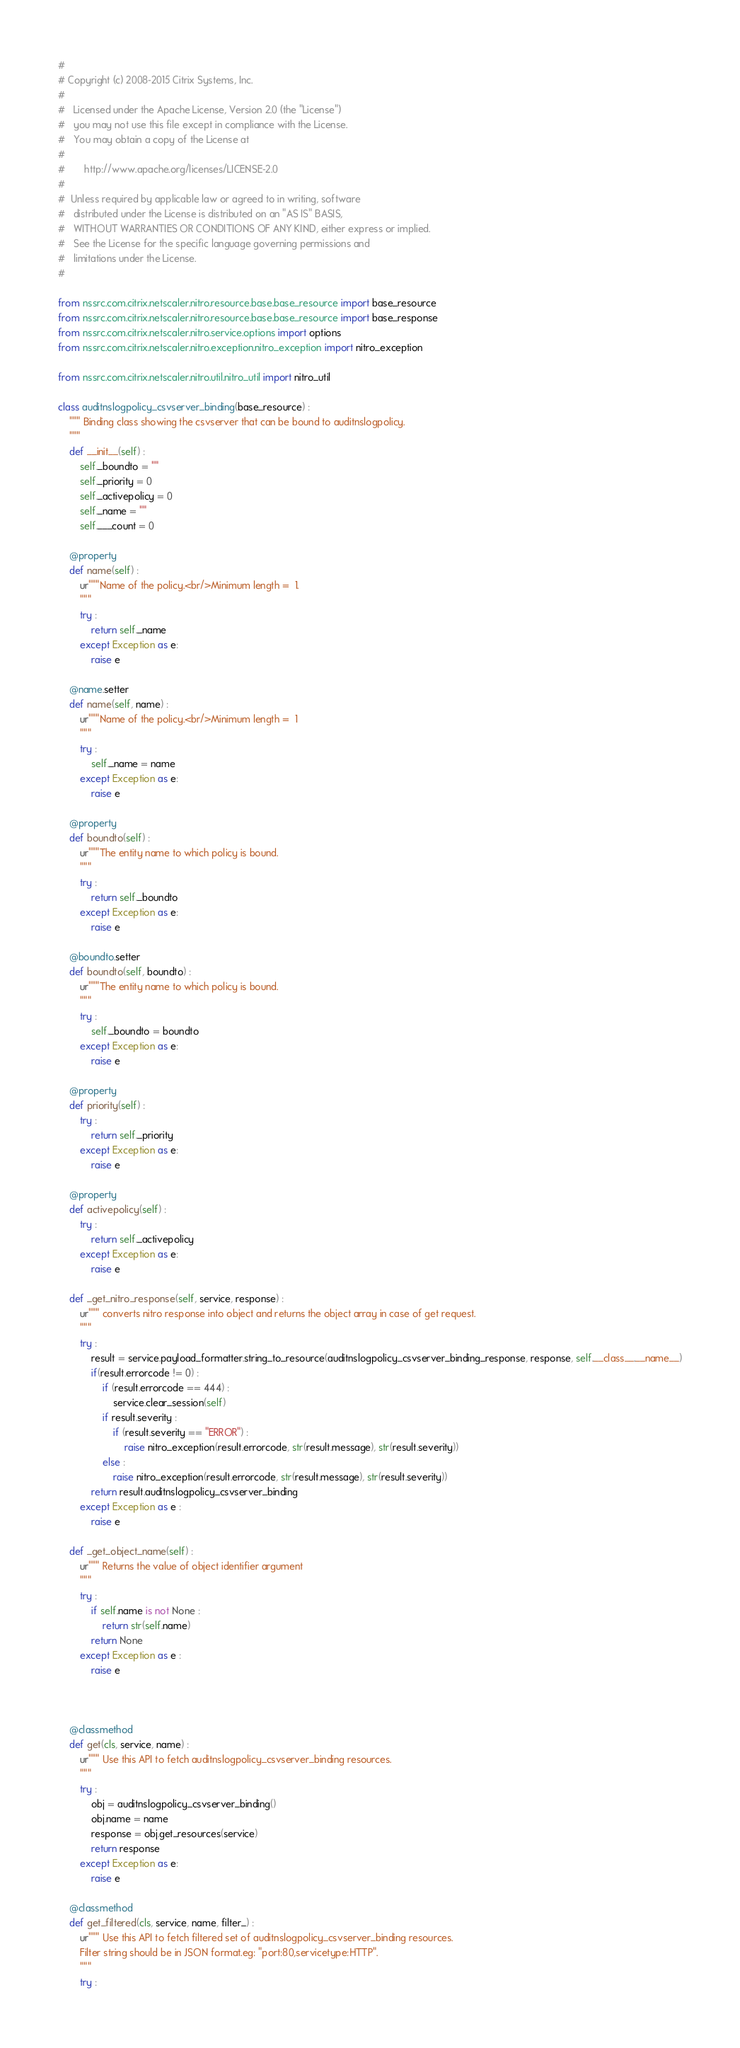<code> <loc_0><loc_0><loc_500><loc_500><_Python_>#
# Copyright (c) 2008-2015 Citrix Systems, Inc.
#
#   Licensed under the Apache License, Version 2.0 (the "License")
#   you may not use this file except in compliance with the License.
#   You may obtain a copy of the License at
#
#       http://www.apache.org/licenses/LICENSE-2.0
#
#  Unless required by applicable law or agreed to in writing, software
#   distributed under the License is distributed on an "AS IS" BASIS,
#   WITHOUT WARRANTIES OR CONDITIONS OF ANY KIND, either express or implied.
#   See the License for the specific language governing permissions and
#   limitations under the License.
#

from nssrc.com.citrix.netscaler.nitro.resource.base.base_resource import base_resource
from nssrc.com.citrix.netscaler.nitro.resource.base.base_resource import base_response
from nssrc.com.citrix.netscaler.nitro.service.options import options
from nssrc.com.citrix.netscaler.nitro.exception.nitro_exception import nitro_exception

from nssrc.com.citrix.netscaler.nitro.util.nitro_util import nitro_util

class auditnslogpolicy_csvserver_binding(base_resource) :
	""" Binding class showing the csvserver that can be bound to auditnslogpolicy.
	"""
	def __init__(self) :
		self._boundto = ""
		self._priority = 0
		self._activepolicy = 0
		self._name = ""
		self.___count = 0

	@property
	def name(self) :
		ur"""Name of the policy.<br/>Minimum length =  1.
		"""
		try :
			return self._name
		except Exception as e:
			raise e

	@name.setter
	def name(self, name) :
		ur"""Name of the policy.<br/>Minimum length =  1
		"""
		try :
			self._name = name
		except Exception as e:
			raise e

	@property
	def boundto(self) :
		ur"""The entity name to which policy is bound.
		"""
		try :
			return self._boundto
		except Exception as e:
			raise e

	@boundto.setter
	def boundto(self, boundto) :
		ur"""The entity name to which policy is bound.
		"""
		try :
			self._boundto = boundto
		except Exception as e:
			raise e

	@property
	def priority(self) :
		try :
			return self._priority
		except Exception as e:
			raise e

	@property
	def activepolicy(self) :
		try :
			return self._activepolicy
		except Exception as e:
			raise e

	def _get_nitro_response(self, service, response) :
		ur""" converts nitro response into object and returns the object array in case of get request.
		"""
		try :
			result = service.payload_formatter.string_to_resource(auditnslogpolicy_csvserver_binding_response, response, self.__class__.__name__)
			if(result.errorcode != 0) :
				if (result.errorcode == 444) :
					service.clear_session(self)
				if result.severity :
					if (result.severity == "ERROR") :
						raise nitro_exception(result.errorcode, str(result.message), str(result.severity))
				else :
					raise nitro_exception(result.errorcode, str(result.message), str(result.severity))
			return result.auditnslogpolicy_csvserver_binding
		except Exception as e :
			raise e

	def _get_object_name(self) :
		ur""" Returns the value of object identifier argument
		"""
		try :
			if self.name is not None :
				return str(self.name)
			return None
		except Exception as e :
			raise e



	@classmethod
	def get(cls, service, name) :
		ur""" Use this API to fetch auditnslogpolicy_csvserver_binding resources.
		"""
		try :
			obj = auditnslogpolicy_csvserver_binding()
			obj.name = name
			response = obj.get_resources(service)
			return response
		except Exception as e:
			raise e

	@classmethod
	def get_filtered(cls, service, name, filter_) :
		ur""" Use this API to fetch filtered set of auditnslogpolicy_csvserver_binding resources.
		Filter string should be in JSON format.eg: "port:80,servicetype:HTTP".
		"""
		try :</code> 